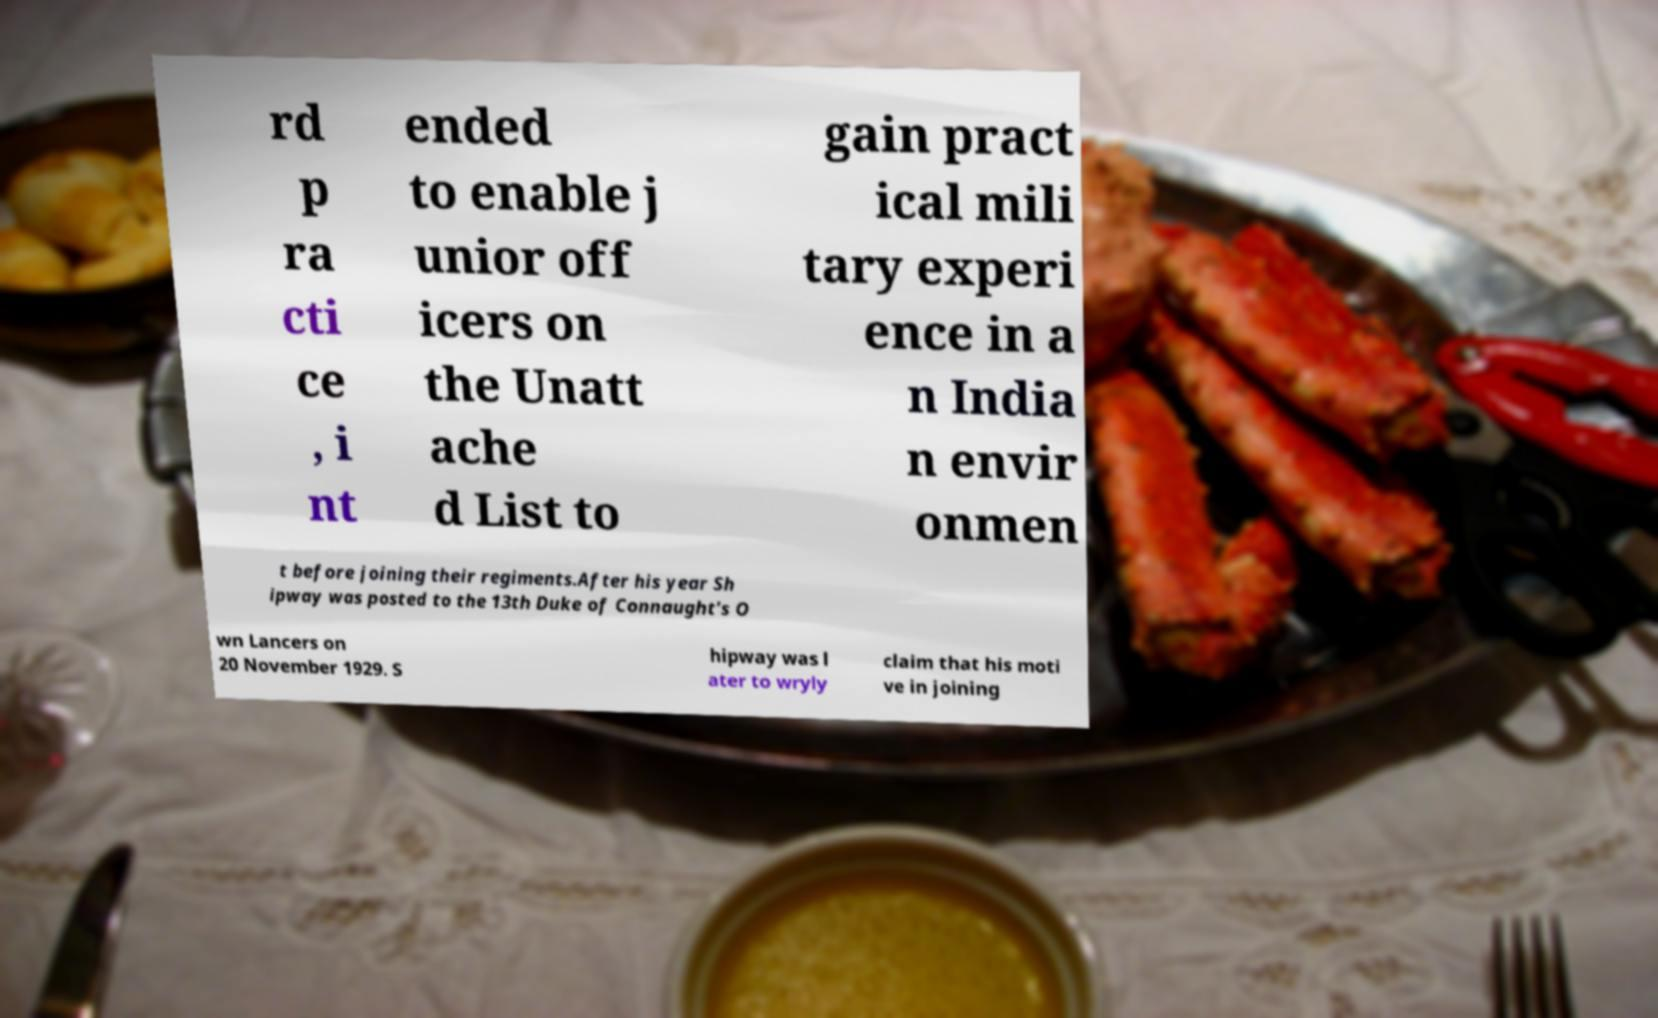Could you assist in decoding the text presented in this image and type it out clearly? rd p ra cti ce , i nt ended to enable j unior off icers on the Unatt ache d List to gain pract ical mili tary experi ence in a n India n envir onmen t before joining their regiments.After his year Sh ipway was posted to the 13th Duke of Connaught's O wn Lancers on 20 November 1929. S hipway was l ater to wryly claim that his moti ve in joining 